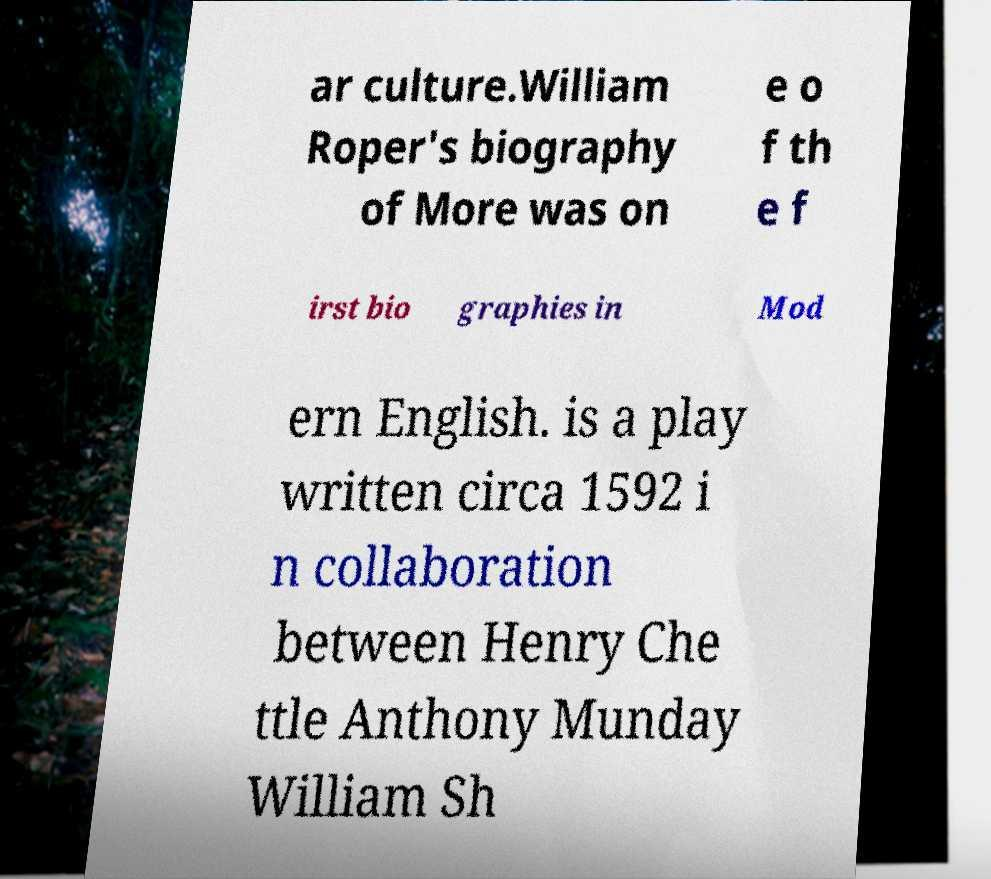Please identify and transcribe the text found in this image. ar culture.William Roper's biography of More was on e o f th e f irst bio graphies in Mod ern English. is a play written circa 1592 i n collaboration between Henry Che ttle Anthony Munday William Sh 